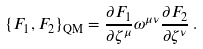Convert formula to latex. <formula><loc_0><loc_0><loc_500><loc_500>\{ F _ { 1 } , F _ { 2 } \} _ { \text {QM} } = \frac { \partial F _ { 1 } } { \partial \zeta ^ { \mu } } \omega ^ { \mu \nu } \frac { \partial F _ { 2 } } { \partial \zeta ^ { \nu } } \, .</formula> 